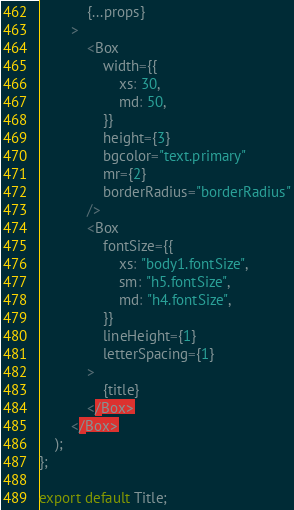<code> <loc_0><loc_0><loc_500><loc_500><_JavaScript_>            {...props}
        >
            <Box
                width={{
                    xs: 30,
                    md: 50,
                }}
                height={3}
                bgcolor="text.primary"
                mr={2}
                borderRadius="borderRadius"
            />
            <Box
                fontSize={{
                    xs: "body1.fontSize",
                    sm: "h5.fontSize",
                    md: "h4.fontSize",
                }}
                lineHeight={1}
                letterSpacing={1}
            >
                {title}
            </Box>
        </Box>
    );
};

export default Title;
</code> 